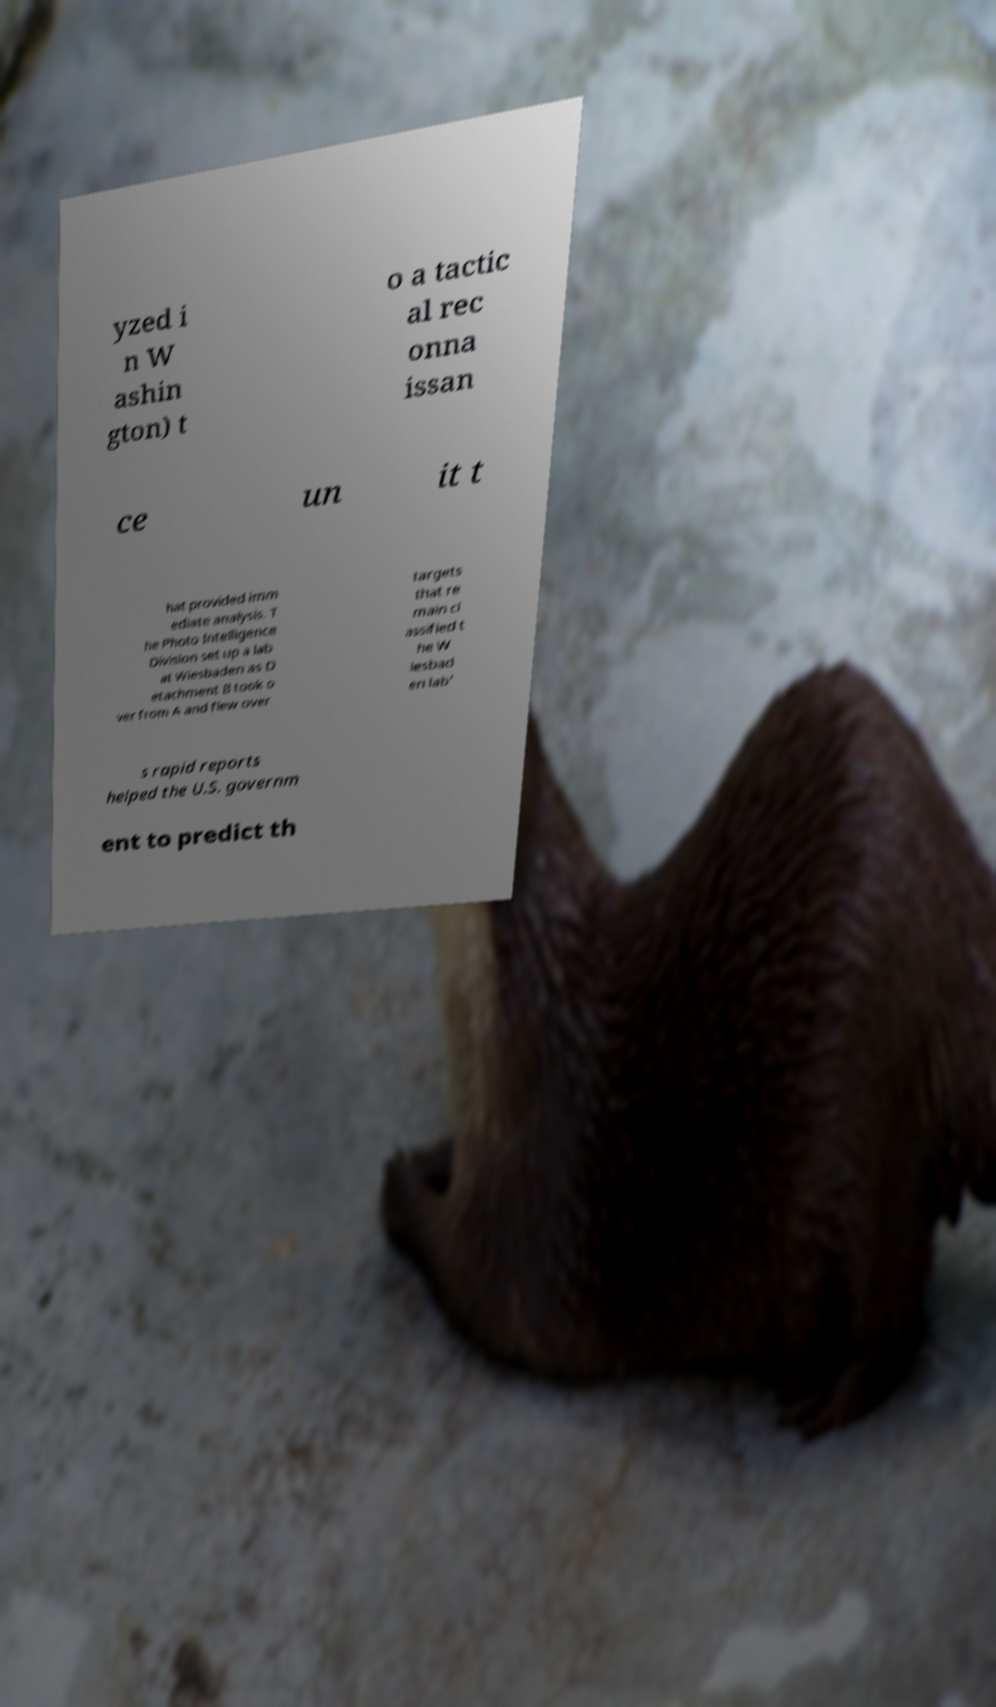Can you read and provide the text displayed in the image?This photo seems to have some interesting text. Can you extract and type it out for me? yzed i n W ashin gton) t o a tactic al rec onna issan ce un it t hat provided imm ediate analysis. T he Photo Intelligence Division set up a lab at Wiesbaden as D etachment B took o ver from A and flew over targets that re main cl assified t he W iesbad en lab' s rapid reports helped the U.S. governm ent to predict th 